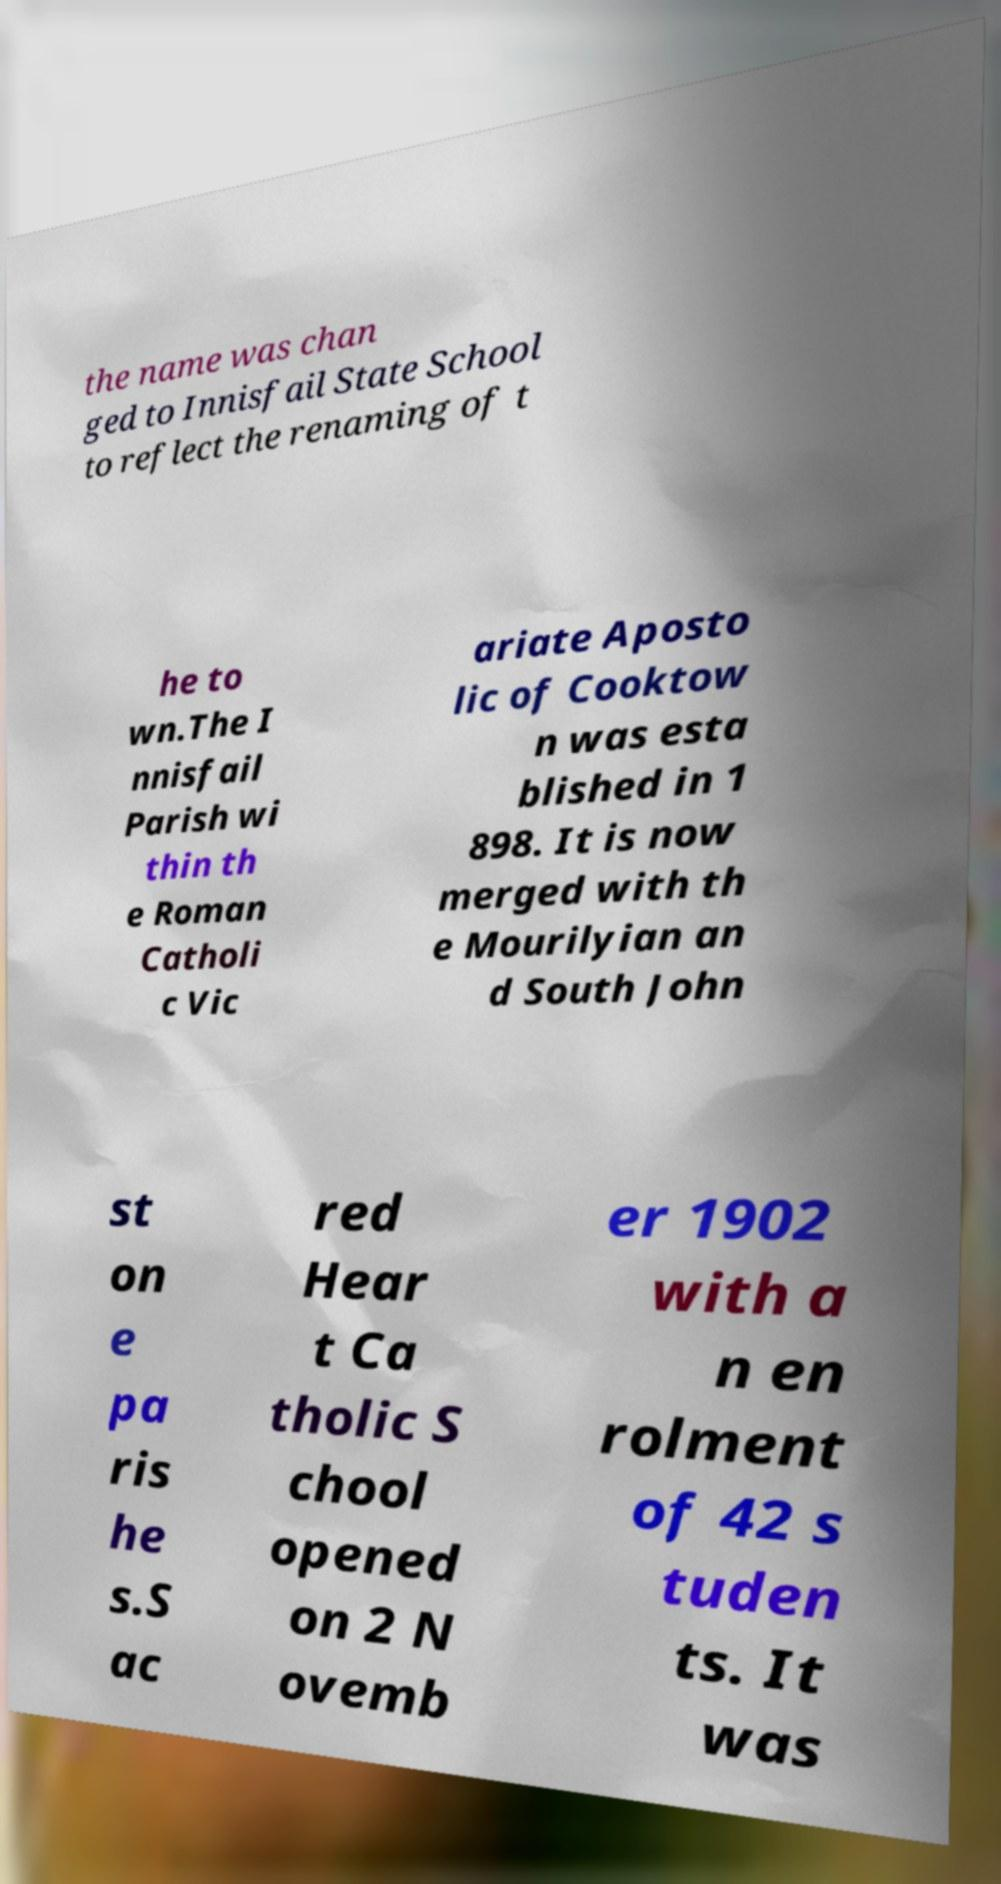For documentation purposes, I need the text within this image transcribed. Could you provide that? the name was chan ged to Innisfail State School to reflect the renaming of t he to wn.The I nnisfail Parish wi thin th e Roman Catholi c Vic ariate Aposto lic of Cooktow n was esta blished in 1 898. It is now merged with th e Mourilyian an d South John st on e pa ris he s.S ac red Hear t Ca tholic S chool opened on 2 N ovemb er 1902 with a n en rolment of 42 s tuden ts. It was 